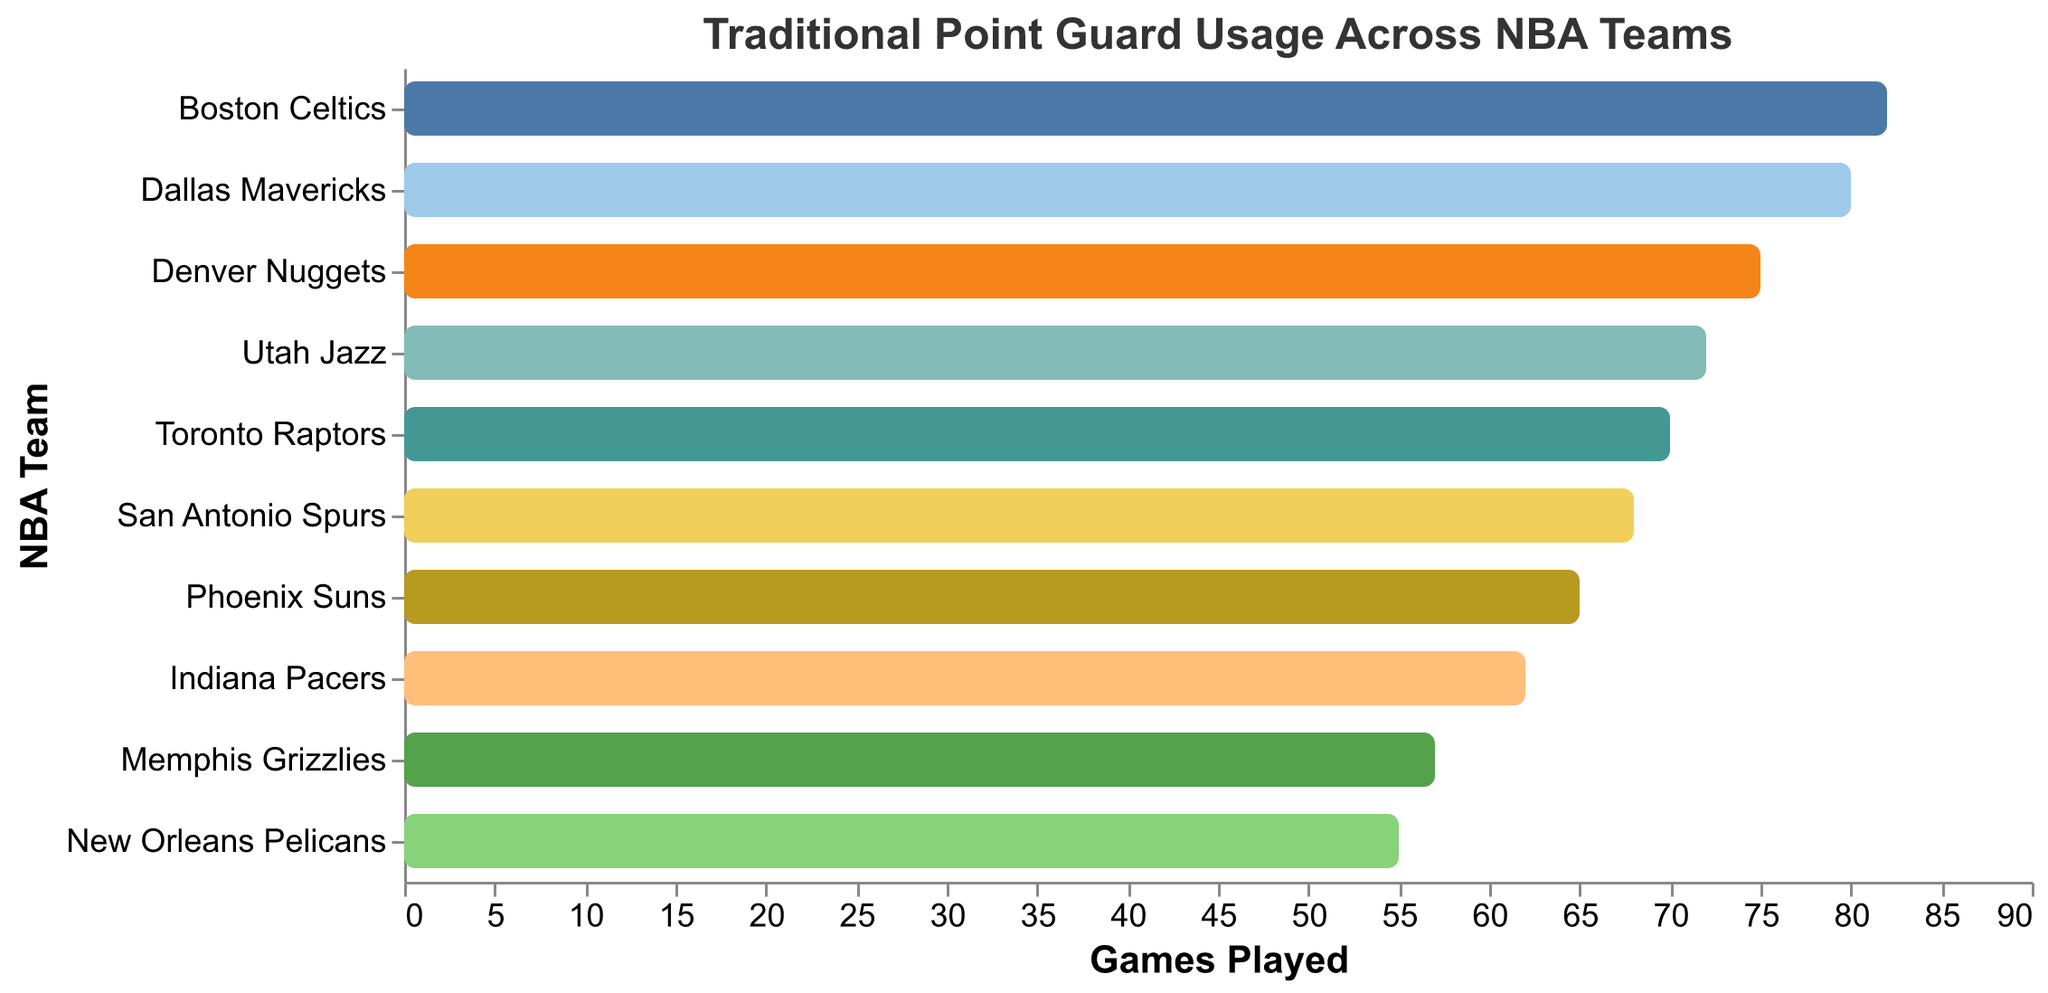what's the title of the figure? The title of the figure is located at the top and is usually descriptive of the content represented in the chart. In this case, the title should describe the theme of the data shown.
Answer: Traditional Point Guard Usage Across NBA Teams How many traditional point guards are compared in the chart? You can determine the number of traditional point guards by counting the number of unique entries in the player field represented in the chart.
Answer: 10 Which player has the highest number of games played? Look for the longest bar on the chart, as this corresponds to the highest "Duration" or the highest number of games played. Identify the player associated with this longest bar.
Answer: Marcus Smart Which player has the lowest number of games played? Look for the shortest bar on the chart, as this corresponds to the lowest "Duration" or the lowest number of games played. Identify the player associated with this shortest bar.
Answer: Lonzo Ball Compare the games played by Chris Paul and Mike Conley. Who played more games and by how many? Locate the bars for Chris Paul and Mike Conley. Compare their lengths to determine who has the longer bar (more games). Subtract the number of games Chris Paul played from the number Mike Conley played.
Answer: Mike Conley played 7 more games What is the average duration of games played by all the players listed? Add up the "Duration" values for all players and then divide by the number of players (10) to find the average number of games played.
Answer: 66.1 games Between Monte Morris and Fred VanVleet, who played fewer games, and what is the difference in games played between them? Locate the bars for Monte Morris and Fred VanVleet. Identify the bar with the shorter length (fewer games played) and subtract the number of games of the player with the shorter bar from the number of the player with the longer bar.
Answer: Fred VanVleet played 5 fewer games Which team used their traditional point guard for the entire season (82 games)? Identify the bar that reaches the maximum possible value, 82 games. Find the team associated with this bar.
Answer: Boston Celtics If you combine the total games played by players from the Western Conference teams (e.g., Phoenix Suns, Utah Jazz, San Antonio Spurs, New Orleans Pelicans, Dallas Mavericks, Denver Nuggets, and Memphis Grizzlies), what is the combined total? Sum the "Duration" values for players from the Western Conference teams. These teams include Phoenix Suns, Utah Jazz, San Antonio Spurs, New Orleans Pelicans, Dallas Mavericks, Denver Nuggets, and Memphis Grizzlies.
Answer: 472 games What's the ratio of total games played by traditional point guards from Eastern Conference teams to those from Western Conference teams? Find the total games played by players from Eastern Conference teams (e.g., Boston Celtics, Toronto Raptors, Indiana Pacers). Add these values and compare this sum to the combined total for Western Conference teams obtained previously. The ratio will be the total from Eastern Conference divided by the total from Western Conference.
Answer: 214:472 